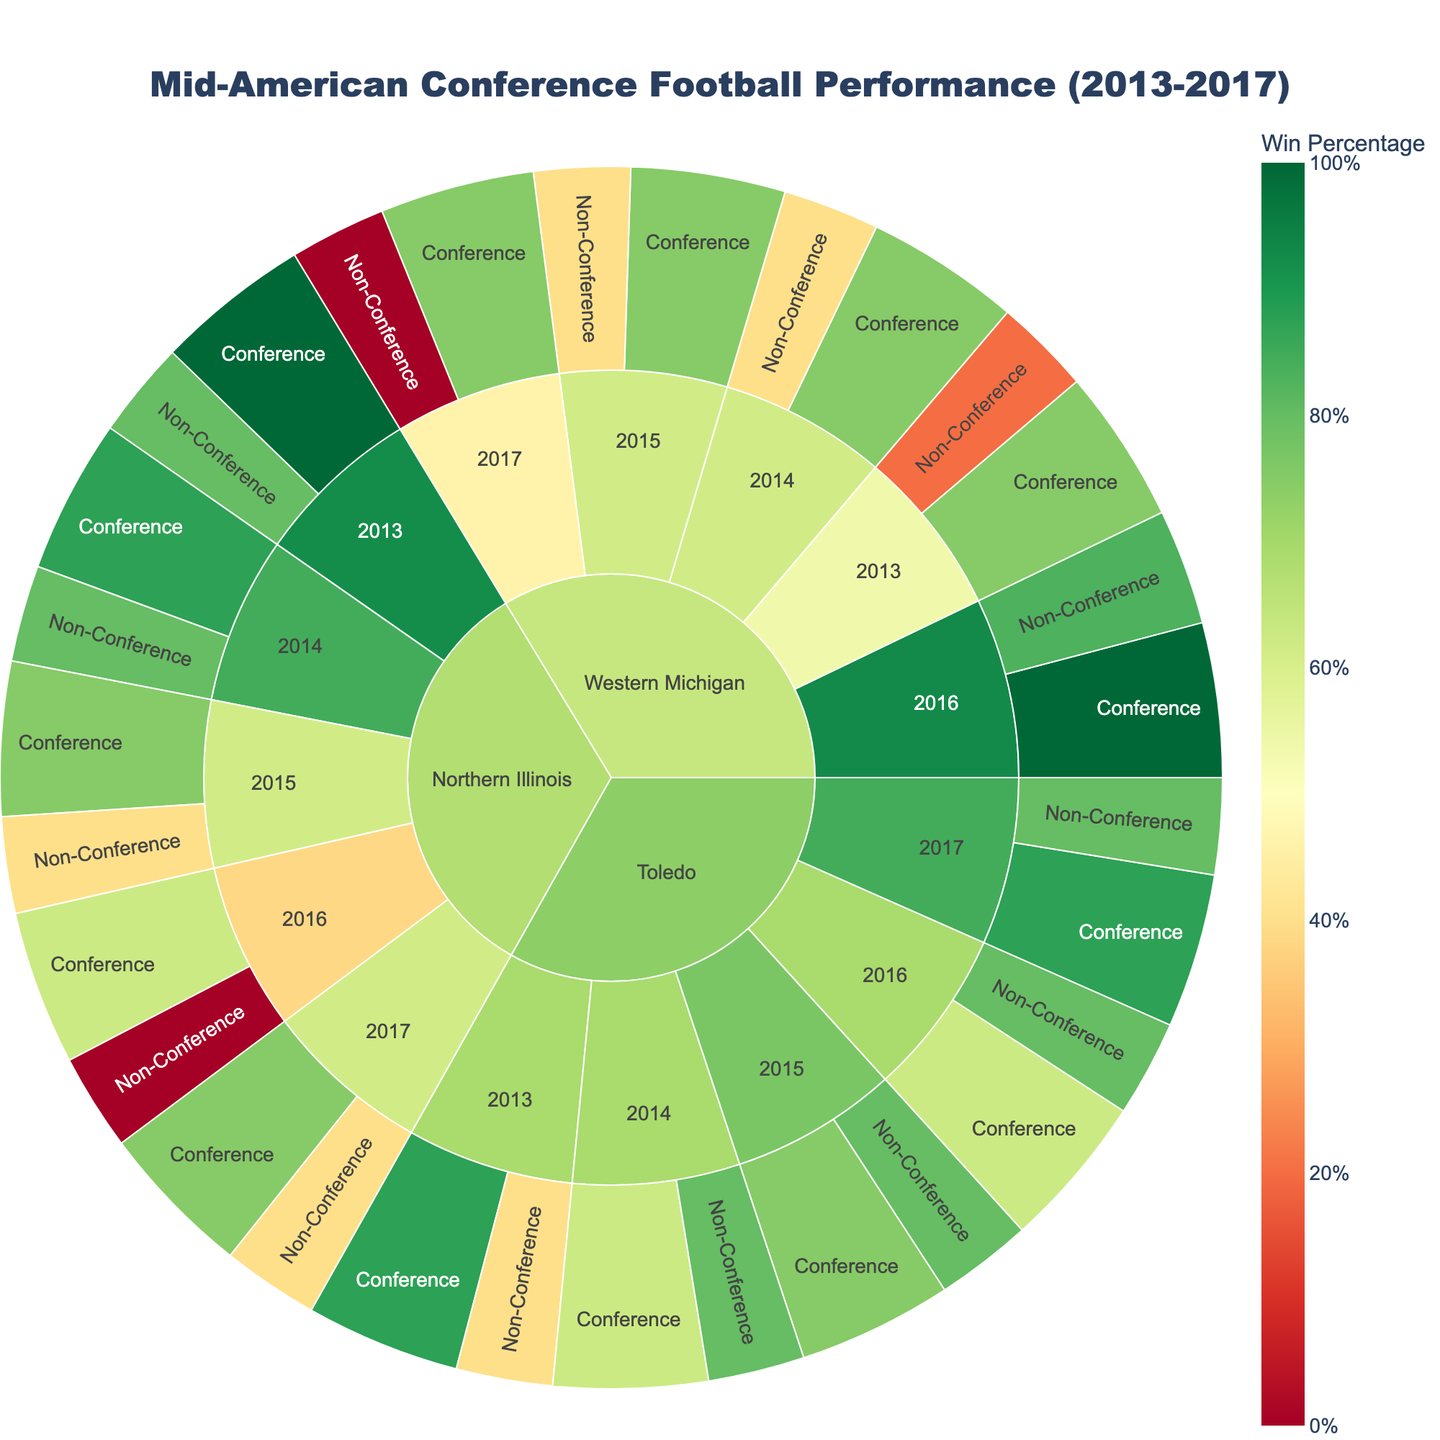what is the win percentage for Toledo in the 2013 Conference season? To find the win percentage for Toledo in the 2013 Conference season, look at the color-coded section labeled Toledo -> 2013 -> Conference. The hover data provides the wins, losses, and win percentage.
Answer: 87.5% What season did Northern Illinois have a perfect Conference record? Browse through the sections for each season under Northern Illinois to find where the Conference win percentage is 100%.
Answer: 2013 How many total games did Western Michigan play against Non-Conference opponents in 2017? Navigate to Western Michigan -> 2017 -> Non-Conference and sum up the wins and losses for that segment.
Answer: 5 Which team had the highest win percentage in the 2016 Conference season? Compare the win percentages for each team under the 2016 -> Conference sections to identify the highest one.
Answer: Western Michigan What is the overall win-loss record for Northern Illinois in 2014? To get the overall win-loss record, sum the wins and losses from both Conference and Non-Conference opponents for Northern Illinois in the 2014 season.
Answer: 11-2 Which team had the worst win percentage against Non-Conference opponents in 2016? Look at the win percentages for Non-Conference games in the 2016 season for each team and identify the lowest one.
Answer: Northern Illinois What was the combined win percentage for Toledo in the 2015 season? Calculate the combined win percentage by considering total wins and losses from both Conference and Non-Conference games in 2015 for Toledo. Total games = 6 + 2 + 4 + 1 = 13, Total wins = 6 + 4 = 10. Win Percentage = (10/13) * 100.
Answer: 76.9% Which team had the most seasons with at least 6 Conference wins between 2013 and 2017? Count the seasons with at least 6 Conference wins for each team.
Answer: Western Michigan In which season did the Non-Conference win percentage for Western Michigan significantly drop compared to the previous seasons? Observe the Non-Conference win percentages for Western Michigan over the seasons and note where there is a significant drop.
Answer: 2017 